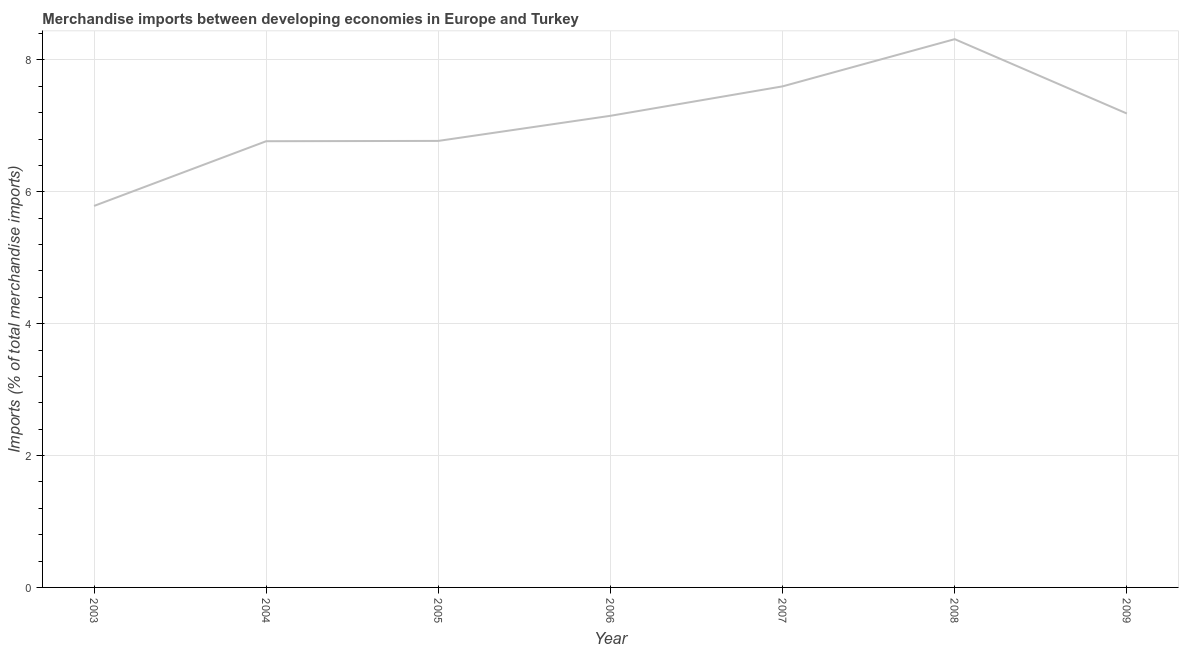What is the merchandise imports in 2009?
Your answer should be compact. 7.19. Across all years, what is the maximum merchandise imports?
Your response must be concise. 8.31. Across all years, what is the minimum merchandise imports?
Offer a terse response. 5.79. In which year was the merchandise imports maximum?
Ensure brevity in your answer.  2008. What is the sum of the merchandise imports?
Make the answer very short. 49.57. What is the difference between the merchandise imports in 2004 and 2009?
Give a very brief answer. -0.42. What is the average merchandise imports per year?
Your answer should be very brief. 7.08. What is the median merchandise imports?
Ensure brevity in your answer.  7.15. Do a majority of the years between 2006 and 2007 (inclusive) have merchandise imports greater than 0.4 %?
Offer a terse response. Yes. What is the ratio of the merchandise imports in 2005 to that in 2007?
Your answer should be compact. 0.89. Is the merchandise imports in 2003 less than that in 2006?
Provide a short and direct response. Yes. What is the difference between the highest and the second highest merchandise imports?
Keep it short and to the point. 0.72. Is the sum of the merchandise imports in 2004 and 2009 greater than the maximum merchandise imports across all years?
Your answer should be compact. Yes. What is the difference between the highest and the lowest merchandise imports?
Offer a very short reply. 2.53. How many lines are there?
Keep it short and to the point. 1. Does the graph contain grids?
Your answer should be very brief. Yes. What is the title of the graph?
Your answer should be very brief. Merchandise imports between developing economies in Europe and Turkey. What is the label or title of the X-axis?
Your response must be concise. Year. What is the label or title of the Y-axis?
Ensure brevity in your answer.  Imports (% of total merchandise imports). What is the Imports (% of total merchandise imports) of 2003?
Your response must be concise. 5.79. What is the Imports (% of total merchandise imports) in 2004?
Your answer should be compact. 6.77. What is the Imports (% of total merchandise imports) of 2005?
Give a very brief answer. 6.77. What is the Imports (% of total merchandise imports) of 2006?
Your answer should be compact. 7.15. What is the Imports (% of total merchandise imports) in 2007?
Provide a succinct answer. 7.6. What is the Imports (% of total merchandise imports) of 2008?
Your answer should be very brief. 8.31. What is the Imports (% of total merchandise imports) in 2009?
Ensure brevity in your answer.  7.19. What is the difference between the Imports (% of total merchandise imports) in 2003 and 2004?
Offer a very short reply. -0.98. What is the difference between the Imports (% of total merchandise imports) in 2003 and 2005?
Offer a very short reply. -0.99. What is the difference between the Imports (% of total merchandise imports) in 2003 and 2006?
Provide a succinct answer. -1.37. What is the difference between the Imports (% of total merchandise imports) in 2003 and 2007?
Provide a short and direct response. -1.81. What is the difference between the Imports (% of total merchandise imports) in 2003 and 2008?
Your response must be concise. -2.53. What is the difference between the Imports (% of total merchandise imports) in 2003 and 2009?
Your response must be concise. -1.4. What is the difference between the Imports (% of total merchandise imports) in 2004 and 2005?
Provide a short and direct response. -0. What is the difference between the Imports (% of total merchandise imports) in 2004 and 2006?
Your answer should be compact. -0.39. What is the difference between the Imports (% of total merchandise imports) in 2004 and 2007?
Your answer should be compact. -0.83. What is the difference between the Imports (% of total merchandise imports) in 2004 and 2008?
Make the answer very short. -1.55. What is the difference between the Imports (% of total merchandise imports) in 2004 and 2009?
Your answer should be very brief. -0.42. What is the difference between the Imports (% of total merchandise imports) in 2005 and 2006?
Provide a succinct answer. -0.38. What is the difference between the Imports (% of total merchandise imports) in 2005 and 2007?
Provide a short and direct response. -0.83. What is the difference between the Imports (% of total merchandise imports) in 2005 and 2008?
Provide a short and direct response. -1.54. What is the difference between the Imports (% of total merchandise imports) in 2005 and 2009?
Give a very brief answer. -0.42. What is the difference between the Imports (% of total merchandise imports) in 2006 and 2007?
Give a very brief answer. -0.45. What is the difference between the Imports (% of total merchandise imports) in 2006 and 2008?
Your response must be concise. -1.16. What is the difference between the Imports (% of total merchandise imports) in 2006 and 2009?
Offer a terse response. -0.03. What is the difference between the Imports (% of total merchandise imports) in 2007 and 2008?
Your answer should be very brief. -0.72. What is the difference between the Imports (% of total merchandise imports) in 2007 and 2009?
Make the answer very short. 0.41. What is the difference between the Imports (% of total merchandise imports) in 2008 and 2009?
Your answer should be very brief. 1.13. What is the ratio of the Imports (% of total merchandise imports) in 2003 to that in 2004?
Your answer should be very brief. 0.85. What is the ratio of the Imports (% of total merchandise imports) in 2003 to that in 2005?
Your response must be concise. 0.85. What is the ratio of the Imports (% of total merchandise imports) in 2003 to that in 2006?
Your answer should be compact. 0.81. What is the ratio of the Imports (% of total merchandise imports) in 2003 to that in 2007?
Your answer should be compact. 0.76. What is the ratio of the Imports (% of total merchandise imports) in 2003 to that in 2008?
Your answer should be compact. 0.7. What is the ratio of the Imports (% of total merchandise imports) in 2003 to that in 2009?
Give a very brief answer. 0.81. What is the ratio of the Imports (% of total merchandise imports) in 2004 to that in 2005?
Provide a short and direct response. 1. What is the ratio of the Imports (% of total merchandise imports) in 2004 to that in 2006?
Keep it short and to the point. 0.95. What is the ratio of the Imports (% of total merchandise imports) in 2004 to that in 2007?
Keep it short and to the point. 0.89. What is the ratio of the Imports (% of total merchandise imports) in 2004 to that in 2008?
Keep it short and to the point. 0.81. What is the ratio of the Imports (% of total merchandise imports) in 2004 to that in 2009?
Keep it short and to the point. 0.94. What is the ratio of the Imports (% of total merchandise imports) in 2005 to that in 2006?
Your answer should be compact. 0.95. What is the ratio of the Imports (% of total merchandise imports) in 2005 to that in 2007?
Ensure brevity in your answer.  0.89. What is the ratio of the Imports (% of total merchandise imports) in 2005 to that in 2008?
Your response must be concise. 0.81. What is the ratio of the Imports (% of total merchandise imports) in 2005 to that in 2009?
Offer a very short reply. 0.94. What is the ratio of the Imports (% of total merchandise imports) in 2006 to that in 2007?
Keep it short and to the point. 0.94. What is the ratio of the Imports (% of total merchandise imports) in 2006 to that in 2008?
Keep it short and to the point. 0.86. What is the ratio of the Imports (% of total merchandise imports) in 2007 to that in 2008?
Ensure brevity in your answer.  0.91. What is the ratio of the Imports (% of total merchandise imports) in 2007 to that in 2009?
Provide a short and direct response. 1.06. What is the ratio of the Imports (% of total merchandise imports) in 2008 to that in 2009?
Provide a short and direct response. 1.16. 